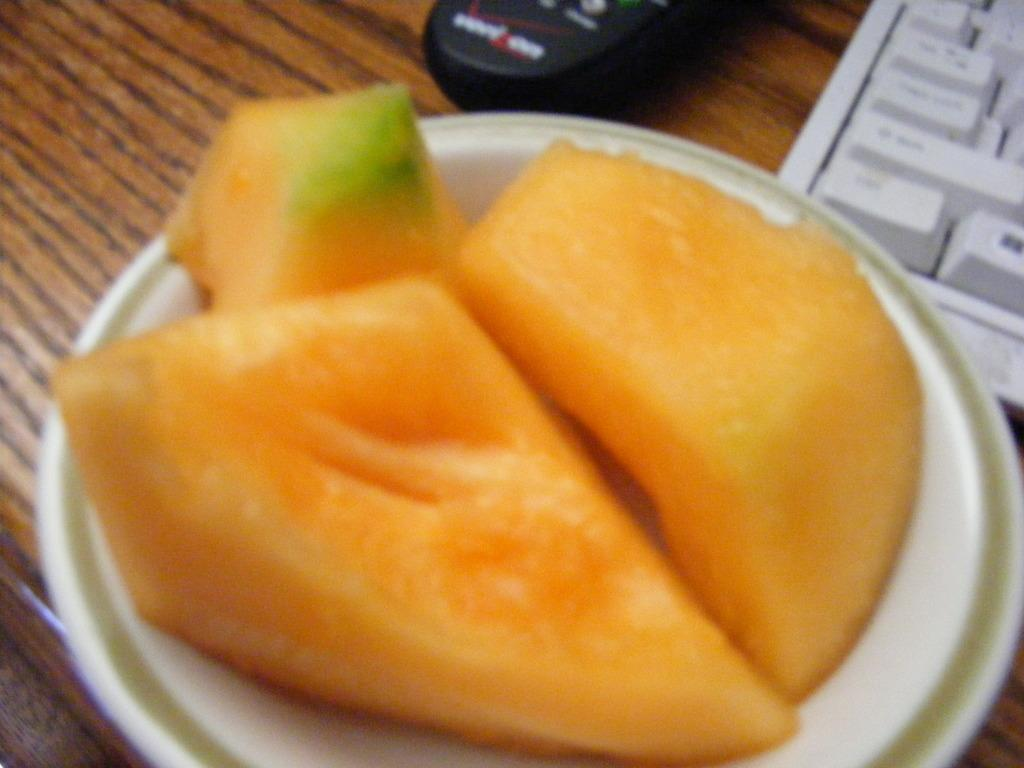What type of surface is visible in the image? There is a wooden surface in the image. What is placed on the wooden surface? There is a gadget and a keyboard on the wooden surface. What is on the plate that is also on the wooden surface? The plate contains pieces of fruit. How many kittens can be seen playing with the goose on the wooden surface? There are no kittens or goose present on the wooden surface in the image. 